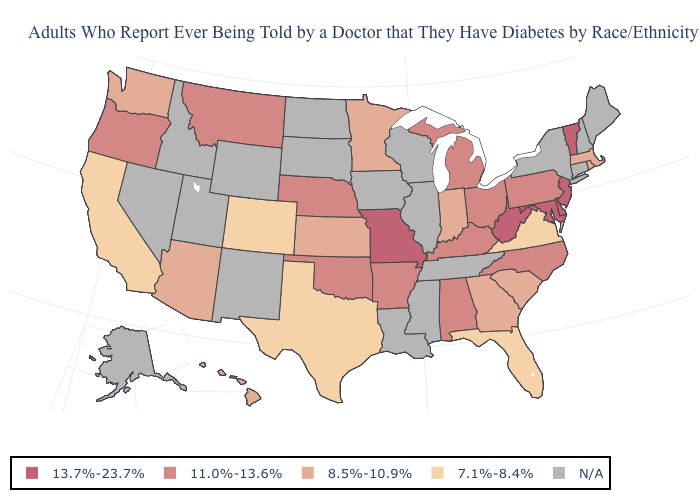Is the legend a continuous bar?
Write a very short answer. No. How many symbols are there in the legend?
Be succinct. 5. What is the value of Maryland?
Concise answer only. 13.7%-23.7%. Among the states that border Oklahoma , which have the lowest value?
Give a very brief answer. Colorado, Texas. Name the states that have a value in the range N/A?
Keep it brief. Alaska, Connecticut, Idaho, Illinois, Iowa, Louisiana, Maine, Mississippi, Nevada, New Hampshire, New Mexico, New York, North Dakota, South Dakota, Tennessee, Utah, Wisconsin, Wyoming. What is the lowest value in states that border Kansas?
Short answer required. 7.1%-8.4%. What is the value of Texas?
Be succinct. 7.1%-8.4%. Does Massachusetts have the lowest value in the Northeast?
Write a very short answer. Yes. What is the highest value in the USA?
Short answer required. 13.7%-23.7%. What is the value of Indiana?
Keep it brief. 8.5%-10.9%. Which states hav the highest value in the West?
Keep it brief. Montana, Oregon. Name the states that have a value in the range 7.1%-8.4%?
Give a very brief answer. California, Colorado, Florida, Texas, Virginia. Is the legend a continuous bar?
Concise answer only. No. Which states have the lowest value in the South?
Keep it brief. Florida, Texas, Virginia. What is the value of Mississippi?
Give a very brief answer. N/A. 